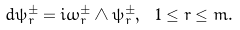Convert formula to latex. <formula><loc_0><loc_0><loc_500><loc_500>d \psi _ { r } ^ { \pm } = i \omega _ { r } ^ { \pm } \wedge \psi _ { r } ^ { \pm } , { \ } 1 \leq r \leq m .</formula> 